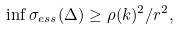Convert formula to latex. <formula><loc_0><loc_0><loc_500><loc_500>\inf \sigma _ { e s s } ( \Delta ) \geq \rho ( k ) ^ { 2 } / r ^ { 2 } ,</formula> 